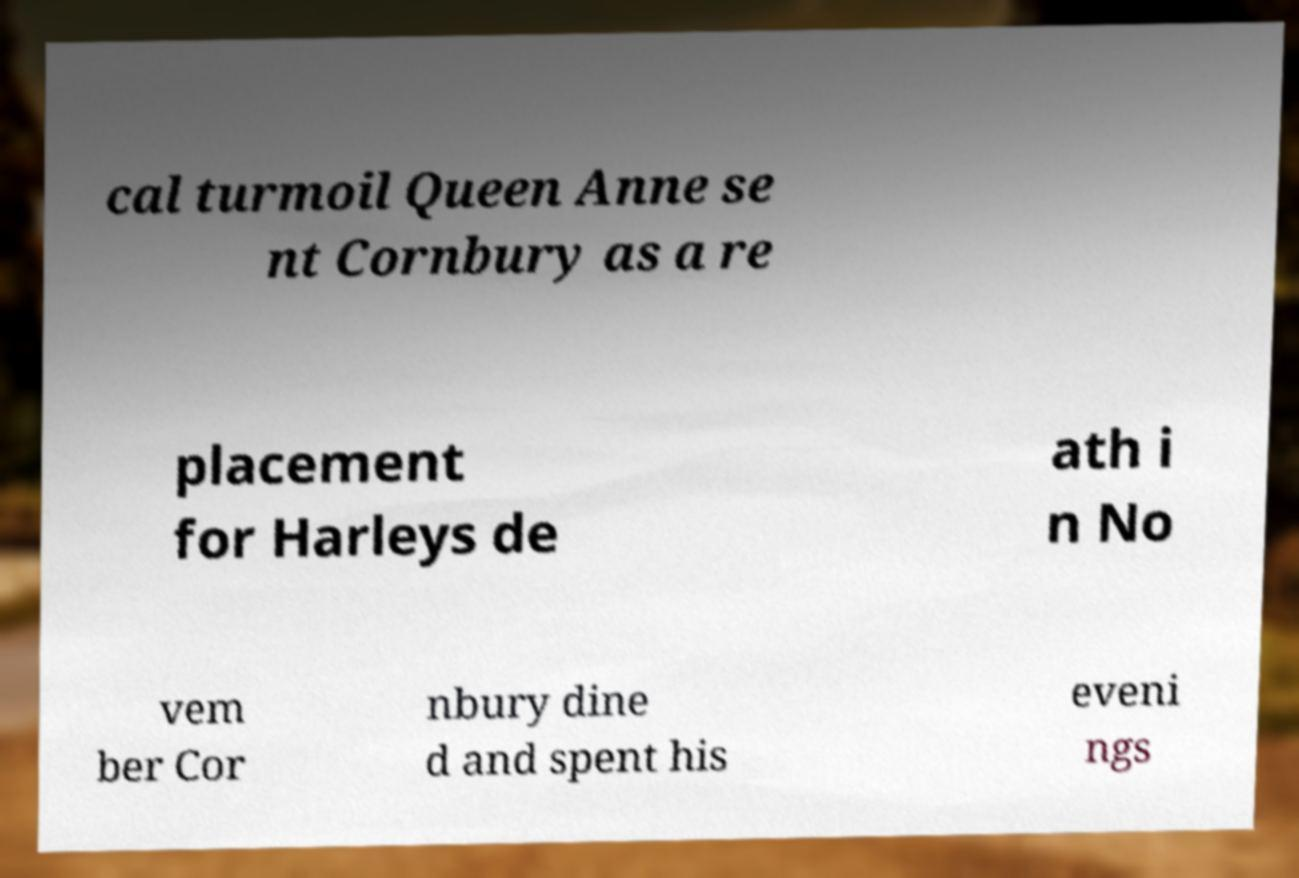Please identify and transcribe the text found in this image. cal turmoil Queen Anne se nt Cornbury as a re placement for Harleys de ath i n No vem ber Cor nbury dine d and spent his eveni ngs 